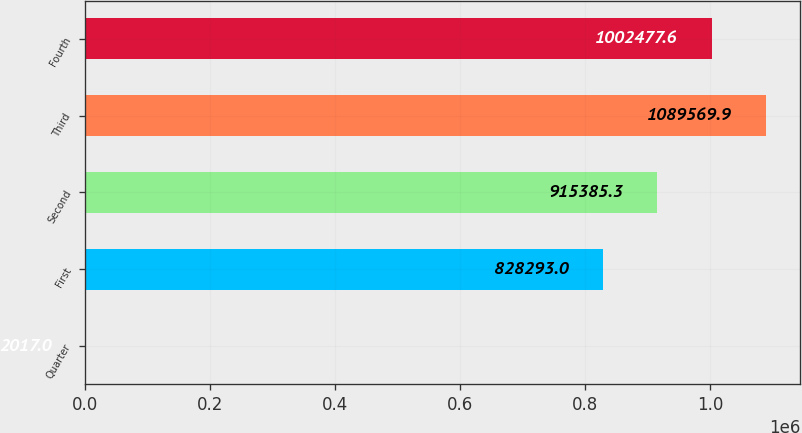<chart> <loc_0><loc_0><loc_500><loc_500><bar_chart><fcel>Quarter<fcel>First<fcel>Second<fcel>Third<fcel>Fourth<nl><fcel>2017<fcel>828293<fcel>915385<fcel>1.08957e+06<fcel>1.00248e+06<nl></chart> 